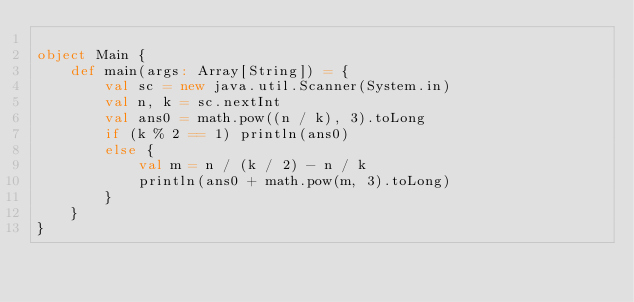<code> <loc_0><loc_0><loc_500><loc_500><_Scala_>
object Main {
    def main(args: Array[String]) = {
        val sc = new java.util.Scanner(System.in)
        val n, k = sc.nextInt
        val ans0 = math.pow((n / k), 3).toLong
        if (k % 2 == 1) println(ans0)
        else {
            val m = n / (k / 2) - n / k
            println(ans0 + math.pow(m, 3).toLong)
        }
    }
}
</code> 